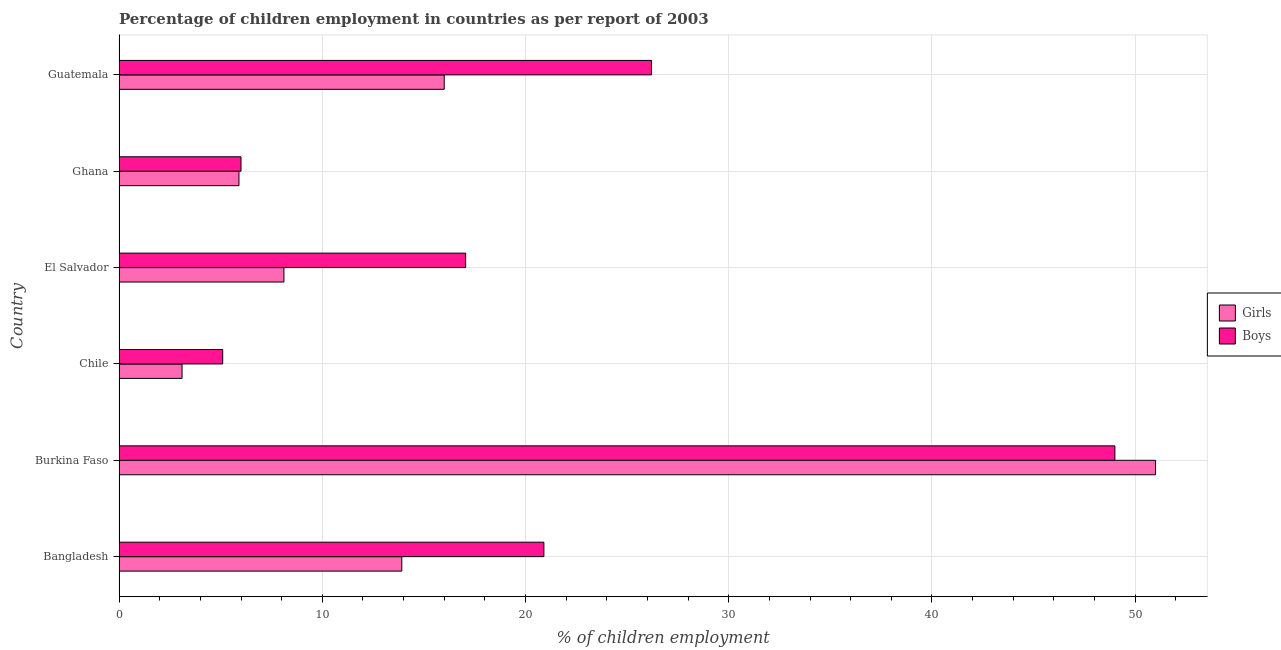How many different coloured bars are there?
Make the answer very short. 2. How many groups of bars are there?
Provide a succinct answer. 6. How many bars are there on the 5th tick from the bottom?
Provide a short and direct response. 2. What is the label of the 3rd group of bars from the top?
Provide a short and direct response. El Salvador. What is the percentage of employed boys in Guatemala?
Ensure brevity in your answer.  26.2. Across all countries, what is the maximum percentage of employed boys?
Provide a succinct answer. 49. Across all countries, what is the minimum percentage of employed boys?
Your response must be concise. 5.1. In which country was the percentage of employed girls maximum?
Provide a succinct answer. Burkina Faso. In which country was the percentage of employed boys minimum?
Offer a very short reply. Chile. What is the total percentage of employed girls in the graph?
Your answer should be compact. 98.03. What is the difference between the percentage of employed boys in Chile and the percentage of employed girls in El Salvador?
Provide a succinct answer. -3.01. What is the average percentage of employed boys per country?
Keep it short and to the point. 20.71. What is the ratio of the percentage of employed girls in Burkina Faso to that in Chile?
Offer a very short reply. 16.45. Is the percentage of employed boys in Bangladesh less than that in Ghana?
Give a very brief answer. No. What is the difference between the highest and the second highest percentage of employed boys?
Give a very brief answer. 22.8. What is the difference between the highest and the lowest percentage of employed girls?
Provide a short and direct response. 47.9. Is the sum of the percentage of employed boys in El Salvador and Ghana greater than the maximum percentage of employed girls across all countries?
Keep it short and to the point. No. What does the 2nd bar from the top in Guatemala represents?
Keep it short and to the point. Girls. What does the 1st bar from the bottom in Guatemala represents?
Your response must be concise. Girls. Are all the bars in the graph horizontal?
Your response must be concise. Yes. What is the difference between two consecutive major ticks on the X-axis?
Give a very brief answer. 10. Where does the legend appear in the graph?
Your answer should be compact. Center right. How many legend labels are there?
Your answer should be very brief. 2. What is the title of the graph?
Your response must be concise. Percentage of children employment in countries as per report of 2003. What is the label or title of the X-axis?
Provide a succinct answer. % of children employment. What is the % of children employment of Girls in Bangladesh?
Provide a short and direct response. 13.91. What is the % of children employment of Boys in Bangladesh?
Ensure brevity in your answer.  20.9. What is the % of children employment in Girls in Burkina Faso?
Your response must be concise. 51. What is the % of children employment in Boys in Burkina Faso?
Your response must be concise. 49. What is the % of children employment of Boys in Chile?
Your answer should be compact. 5.1. What is the % of children employment in Girls in El Salvador?
Keep it short and to the point. 8.11. What is the % of children employment in Boys in El Salvador?
Your answer should be compact. 17.06. What is the % of children employment of Boys in Ghana?
Ensure brevity in your answer.  6. What is the % of children employment in Boys in Guatemala?
Offer a terse response. 26.2. Across all countries, what is the maximum % of children employment in Boys?
Offer a very short reply. 49. Across all countries, what is the minimum % of children employment of Girls?
Keep it short and to the point. 3.1. What is the total % of children employment of Girls in the graph?
Provide a succinct answer. 98.03. What is the total % of children employment in Boys in the graph?
Your response must be concise. 124.26. What is the difference between the % of children employment of Girls in Bangladesh and that in Burkina Faso?
Make the answer very short. -37.09. What is the difference between the % of children employment of Boys in Bangladesh and that in Burkina Faso?
Provide a succinct answer. -28.1. What is the difference between the % of children employment of Girls in Bangladesh and that in Chile?
Offer a very short reply. 10.81. What is the difference between the % of children employment of Boys in Bangladesh and that in Chile?
Keep it short and to the point. 15.8. What is the difference between the % of children employment of Girls in Bangladesh and that in El Salvador?
Keep it short and to the point. 5.8. What is the difference between the % of children employment in Boys in Bangladesh and that in El Salvador?
Make the answer very short. 3.85. What is the difference between the % of children employment of Girls in Bangladesh and that in Ghana?
Ensure brevity in your answer.  8.01. What is the difference between the % of children employment in Boys in Bangladesh and that in Ghana?
Offer a very short reply. 14.9. What is the difference between the % of children employment in Girls in Bangladesh and that in Guatemala?
Provide a short and direct response. -2.09. What is the difference between the % of children employment of Boys in Bangladesh and that in Guatemala?
Your answer should be very brief. -5.3. What is the difference between the % of children employment of Girls in Burkina Faso and that in Chile?
Keep it short and to the point. 47.9. What is the difference between the % of children employment in Boys in Burkina Faso and that in Chile?
Provide a short and direct response. 43.9. What is the difference between the % of children employment of Girls in Burkina Faso and that in El Salvador?
Offer a very short reply. 42.89. What is the difference between the % of children employment in Boys in Burkina Faso and that in El Salvador?
Keep it short and to the point. 31.94. What is the difference between the % of children employment of Girls in Burkina Faso and that in Ghana?
Make the answer very short. 45.1. What is the difference between the % of children employment in Boys in Burkina Faso and that in Ghana?
Offer a very short reply. 43. What is the difference between the % of children employment of Boys in Burkina Faso and that in Guatemala?
Offer a very short reply. 22.8. What is the difference between the % of children employment in Girls in Chile and that in El Salvador?
Offer a very short reply. -5.01. What is the difference between the % of children employment in Boys in Chile and that in El Salvador?
Your answer should be compact. -11.96. What is the difference between the % of children employment in Girls in Chile and that in Ghana?
Make the answer very short. -2.8. What is the difference between the % of children employment in Boys in Chile and that in Ghana?
Ensure brevity in your answer.  -0.9. What is the difference between the % of children employment of Girls in Chile and that in Guatemala?
Your answer should be very brief. -12.9. What is the difference between the % of children employment in Boys in Chile and that in Guatemala?
Offer a terse response. -21.1. What is the difference between the % of children employment of Girls in El Salvador and that in Ghana?
Your answer should be very brief. 2.21. What is the difference between the % of children employment in Boys in El Salvador and that in Ghana?
Your answer should be compact. 11.06. What is the difference between the % of children employment in Girls in El Salvador and that in Guatemala?
Your answer should be compact. -7.89. What is the difference between the % of children employment of Boys in El Salvador and that in Guatemala?
Offer a very short reply. -9.14. What is the difference between the % of children employment of Girls in Ghana and that in Guatemala?
Your answer should be compact. -10.1. What is the difference between the % of children employment in Boys in Ghana and that in Guatemala?
Offer a very short reply. -20.2. What is the difference between the % of children employment of Girls in Bangladesh and the % of children employment of Boys in Burkina Faso?
Keep it short and to the point. -35.09. What is the difference between the % of children employment in Girls in Bangladesh and the % of children employment in Boys in Chile?
Ensure brevity in your answer.  8.81. What is the difference between the % of children employment of Girls in Bangladesh and the % of children employment of Boys in El Salvador?
Your answer should be very brief. -3.14. What is the difference between the % of children employment of Girls in Bangladesh and the % of children employment of Boys in Ghana?
Give a very brief answer. 7.91. What is the difference between the % of children employment in Girls in Bangladesh and the % of children employment in Boys in Guatemala?
Your response must be concise. -12.29. What is the difference between the % of children employment in Girls in Burkina Faso and the % of children employment in Boys in Chile?
Your answer should be compact. 45.9. What is the difference between the % of children employment of Girls in Burkina Faso and the % of children employment of Boys in El Salvador?
Provide a succinct answer. 33.94. What is the difference between the % of children employment of Girls in Burkina Faso and the % of children employment of Boys in Guatemala?
Ensure brevity in your answer.  24.8. What is the difference between the % of children employment in Girls in Chile and the % of children employment in Boys in El Salvador?
Your response must be concise. -13.96. What is the difference between the % of children employment of Girls in Chile and the % of children employment of Boys in Guatemala?
Give a very brief answer. -23.1. What is the difference between the % of children employment of Girls in El Salvador and the % of children employment of Boys in Ghana?
Your answer should be very brief. 2.11. What is the difference between the % of children employment of Girls in El Salvador and the % of children employment of Boys in Guatemala?
Offer a very short reply. -18.09. What is the difference between the % of children employment of Girls in Ghana and the % of children employment of Boys in Guatemala?
Your answer should be compact. -20.3. What is the average % of children employment in Girls per country?
Provide a succinct answer. 16.34. What is the average % of children employment in Boys per country?
Provide a short and direct response. 20.71. What is the difference between the % of children employment in Girls and % of children employment in Boys in Bangladesh?
Offer a terse response. -6.99. What is the difference between the % of children employment of Girls and % of children employment of Boys in Burkina Faso?
Give a very brief answer. 2. What is the difference between the % of children employment of Girls and % of children employment of Boys in Chile?
Ensure brevity in your answer.  -2. What is the difference between the % of children employment of Girls and % of children employment of Boys in El Salvador?
Offer a very short reply. -8.94. What is the difference between the % of children employment in Girls and % of children employment in Boys in Ghana?
Your response must be concise. -0.1. What is the difference between the % of children employment in Girls and % of children employment in Boys in Guatemala?
Make the answer very short. -10.2. What is the ratio of the % of children employment in Girls in Bangladesh to that in Burkina Faso?
Keep it short and to the point. 0.27. What is the ratio of the % of children employment of Boys in Bangladesh to that in Burkina Faso?
Make the answer very short. 0.43. What is the ratio of the % of children employment in Girls in Bangladesh to that in Chile?
Keep it short and to the point. 4.49. What is the ratio of the % of children employment of Boys in Bangladesh to that in Chile?
Provide a short and direct response. 4.1. What is the ratio of the % of children employment in Girls in Bangladesh to that in El Salvador?
Make the answer very short. 1.72. What is the ratio of the % of children employment of Boys in Bangladesh to that in El Salvador?
Give a very brief answer. 1.23. What is the ratio of the % of children employment of Girls in Bangladesh to that in Ghana?
Give a very brief answer. 2.36. What is the ratio of the % of children employment in Boys in Bangladesh to that in Ghana?
Your answer should be very brief. 3.48. What is the ratio of the % of children employment of Girls in Bangladesh to that in Guatemala?
Keep it short and to the point. 0.87. What is the ratio of the % of children employment of Boys in Bangladesh to that in Guatemala?
Ensure brevity in your answer.  0.8. What is the ratio of the % of children employment of Girls in Burkina Faso to that in Chile?
Your answer should be very brief. 16.45. What is the ratio of the % of children employment of Boys in Burkina Faso to that in Chile?
Keep it short and to the point. 9.61. What is the ratio of the % of children employment in Girls in Burkina Faso to that in El Salvador?
Keep it short and to the point. 6.29. What is the ratio of the % of children employment of Boys in Burkina Faso to that in El Salvador?
Keep it short and to the point. 2.87. What is the ratio of the % of children employment of Girls in Burkina Faso to that in Ghana?
Provide a succinct answer. 8.64. What is the ratio of the % of children employment in Boys in Burkina Faso to that in Ghana?
Provide a succinct answer. 8.17. What is the ratio of the % of children employment in Girls in Burkina Faso to that in Guatemala?
Offer a terse response. 3.19. What is the ratio of the % of children employment of Boys in Burkina Faso to that in Guatemala?
Provide a short and direct response. 1.87. What is the ratio of the % of children employment of Girls in Chile to that in El Salvador?
Provide a short and direct response. 0.38. What is the ratio of the % of children employment in Boys in Chile to that in El Salvador?
Offer a terse response. 0.3. What is the ratio of the % of children employment in Girls in Chile to that in Ghana?
Your answer should be very brief. 0.53. What is the ratio of the % of children employment of Girls in Chile to that in Guatemala?
Your response must be concise. 0.19. What is the ratio of the % of children employment of Boys in Chile to that in Guatemala?
Ensure brevity in your answer.  0.19. What is the ratio of the % of children employment in Girls in El Salvador to that in Ghana?
Provide a short and direct response. 1.38. What is the ratio of the % of children employment of Boys in El Salvador to that in Ghana?
Your answer should be compact. 2.84. What is the ratio of the % of children employment in Girls in El Salvador to that in Guatemala?
Ensure brevity in your answer.  0.51. What is the ratio of the % of children employment of Boys in El Salvador to that in Guatemala?
Provide a succinct answer. 0.65. What is the ratio of the % of children employment of Girls in Ghana to that in Guatemala?
Offer a terse response. 0.37. What is the ratio of the % of children employment in Boys in Ghana to that in Guatemala?
Make the answer very short. 0.23. What is the difference between the highest and the second highest % of children employment of Girls?
Your response must be concise. 35. What is the difference between the highest and the second highest % of children employment of Boys?
Your response must be concise. 22.8. What is the difference between the highest and the lowest % of children employment in Girls?
Keep it short and to the point. 47.9. What is the difference between the highest and the lowest % of children employment in Boys?
Make the answer very short. 43.9. 